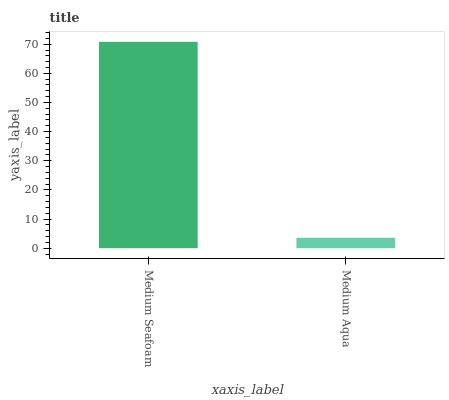Is Medium Aqua the minimum?
Answer yes or no. Yes. Is Medium Seafoam the maximum?
Answer yes or no. Yes. Is Medium Aqua the maximum?
Answer yes or no. No. Is Medium Seafoam greater than Medium Aqua?
Answer yes or no. Yes. Is Medium Aqua less than Medium Seafoam?
Answer yes or no. Yes. Is Medium Aqua greater than Medium Seafoam?
Answer yes or no. No. Is Medium Seafoam less than Medium Aqua?
Answer yes or no. No. Is Medium Seafoam the high median?
Answer yes or no. Yes. Is Medium Aqua the low median?
Answer yes or no. Yes. Is Medium Aqua the high median?
Answer yes or no. No. Is Medium Seafoam the low median?
Answer yes or no. No. 